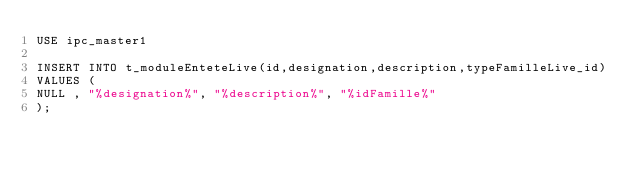Convert code to text. <code><loc_0><loc_0><loc_500><loc_500><_SQL_>USE ipc_master1

INSERT INTO t_moduleEnteteLive(id,designation,description,typeFamilleLive_id)
VALUES (
NULL , "%designation%", "%description%", "%idFamille%"
);
</code> 